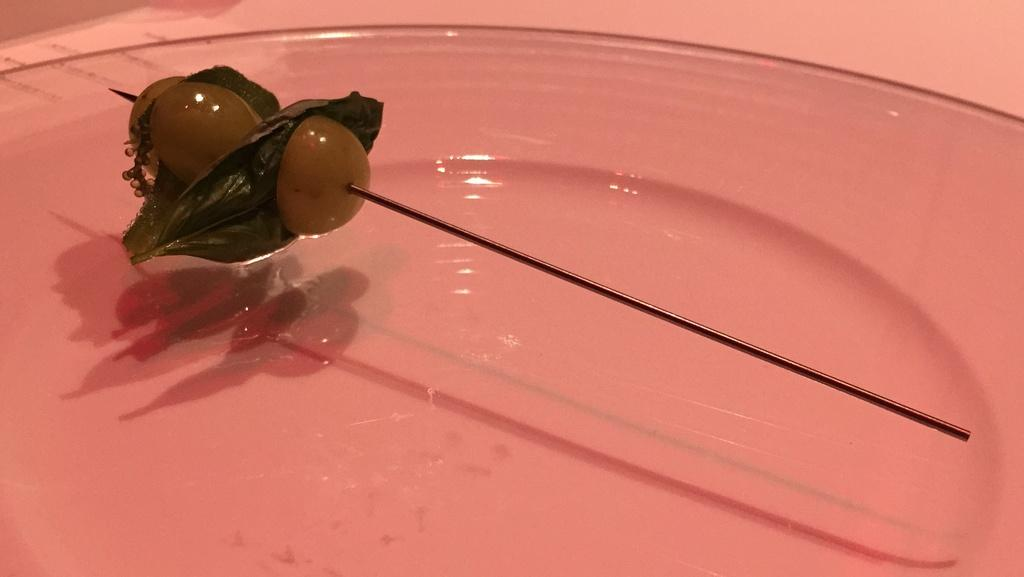What is on the plate in the image? There is water in the plate. What is attached to the needle in the image? Grapes and leaves are pinned to the needle. Can you describe the needle in the image? The needle is used to hold grapes and leaves in place. What type of note is attached to the grapes in the image? There is no note attached to the grapes in the image. 